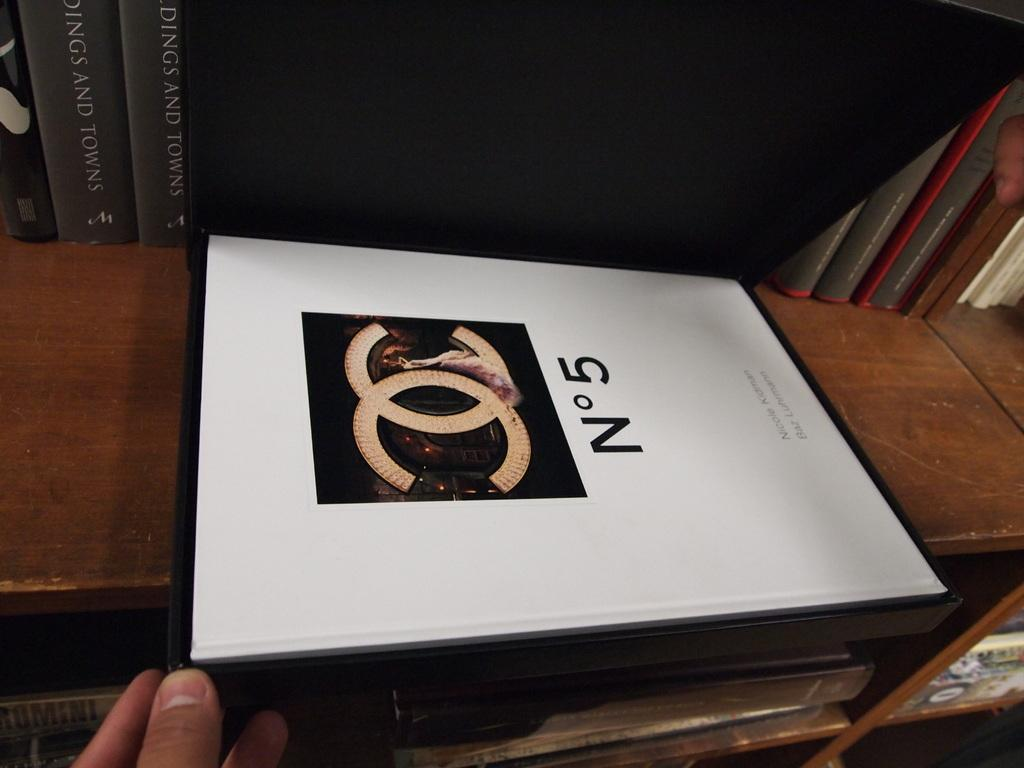What objects can be seen on the bookshelf in the image? There are books on a bookshelf in the image. What is the person's hand doing in the image? The person's hand is holding a book in the center of the image. What type of bat can be seen flying in the image? There is no bat present in the image; it only features books on a bookshelf and a person's hand holding a book. 